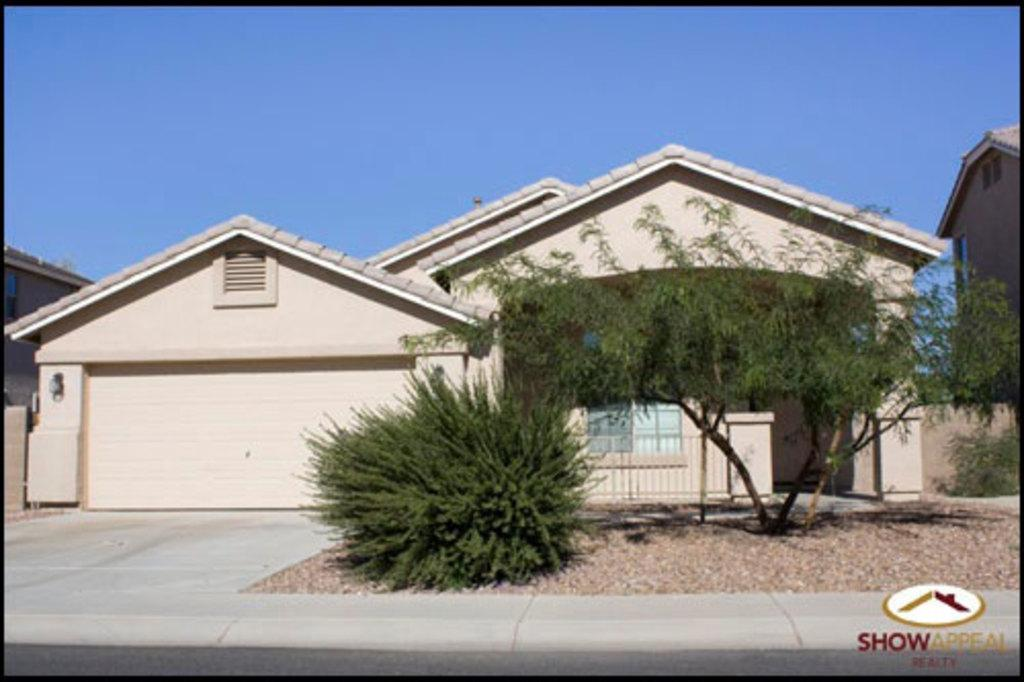What type of vegetation can be seen in the image? There are trees in the image. What is the color of the trees? The trees are green in color. What can be seen in the background of the image? There are buildings in the background of the image. What colors are the buildings? The buildings are in cream and brown colors. What is the color of the sky in the image? The sky is blue in color. How many rings are hanging from the branches of the trees in the image? There are no rings hanging from the branches of the trees in the image. What type of doll can be seen playing with the pump in the image? There is no doll or pump present in the image. 